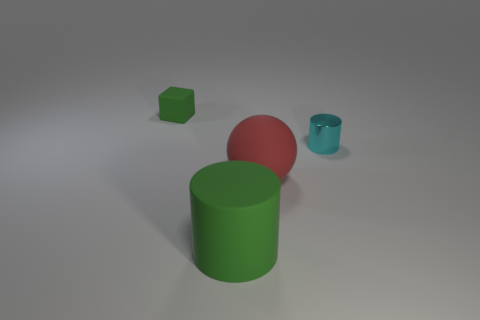Is the big cylinder the same color as the cube?
Your response must be concise. Yes. There is a tiny object behind the cylinder behind the large red sphere; what is its color?
Make the answer very short. Green. How many small things are both in front of the matte block and behind the small cyan thing?
Give a very brief answer. 0. What number of big red objects are the same shape as the cyan metal thing?
Your answer should be compact. 0. Are the small cylinder and the small cube made of the same material?
Your response must be concise. No. There is a green rubber thing in front of the object that is behind the metal cylinder; what is its shape?
Keep it short and to the point. Cylinder. There is a small object left of the rubber cylinder; what number of large rubber cylinders are to the right of it?
Offer a very short reply. 1. What is the material of the object that is on the left side of the large sphere and in front of the small matte object?
Provide a succinct answer. Rubber. There is a cyan thing that is the same size as the matte block; what is its shape?
Your answer should be compact. Cylinder. What color is the cylinder right of the big thing that is behind the cylinder that is on the left side of the tiny metallic object?
Give a very brief answer. Cyan. 